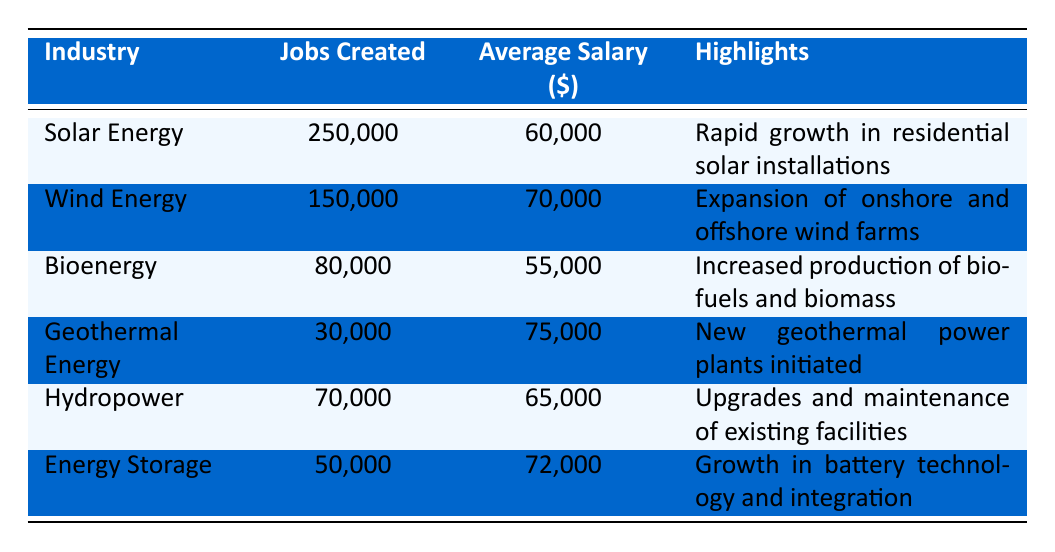What industry created the most jobs in 2022? By examining the "Jobs Created" column in the table, we see that "Solar Energy" has the highest value at 250,000 jobs.
Answer: Solar Energy What is the average salary in the Wind Energy sector? The "Average Salary" for "Wind Energy" is listed in the corresponding cell, which shows a value of $70,000.
Answer: 70000 How many jobs were created in the Bioenergy sector compared to Hydropower? According to the table, Bioenergy created 80,000 jobs while Hydropower created 70,000. The difference in jobs created is 80,000 - 70,000 = 10,000 jobs more for Bioenergy.
Answer: Bioenergy created 10,000 more jobs Which sector has the highest average salary, and what is that salary? Looking at the "Average Salary" column, we find that "Geothermal Energy" has the highest salary at $75,000.
Answer: 75000 Did Energy Storage create less than 60,000 jobs? The table indicates that "Energy Storage" created 50,000 jobs. Since 50,000 is less than 60,000, the statement is true.
Answer: Yes What is the total number of jobs created across all industries listed? To find the total, we add the jobs created across all industries: 250,000 + 150,000 + 80,000 + 30,000 + 70,000 + 50,000 = 630,000.
Answer: 630000 Which sectors have an average salary above $65,000? Checking the "Average Salary" column, we see that "Wind Energy" ($70,000), "Geothermal Energy" ($75,000), and "Energy Storage" ($72,000) all have salaries above $65,000.
Answer: Wind Energy, Geothermal Energy, Energy Storage Is the highlight for the Hydropower sector about new facility construction? The highlight for "Hydropower" states "Upgrades and maintenance of existing facilities," which does not indicate new construction. Thus, the statement is false.
Answer: No What is the average salary across the Solar Energy and Bioenergy sectors? The average salary can be calculated by adding the salaries of both sectors: $60,000 (Solar Energy) + $55,000 (Bioenergy) = $115,000. Then we divide by 2 to find the average: $115,000 / 2 = $57,500.
Answer: 57500 